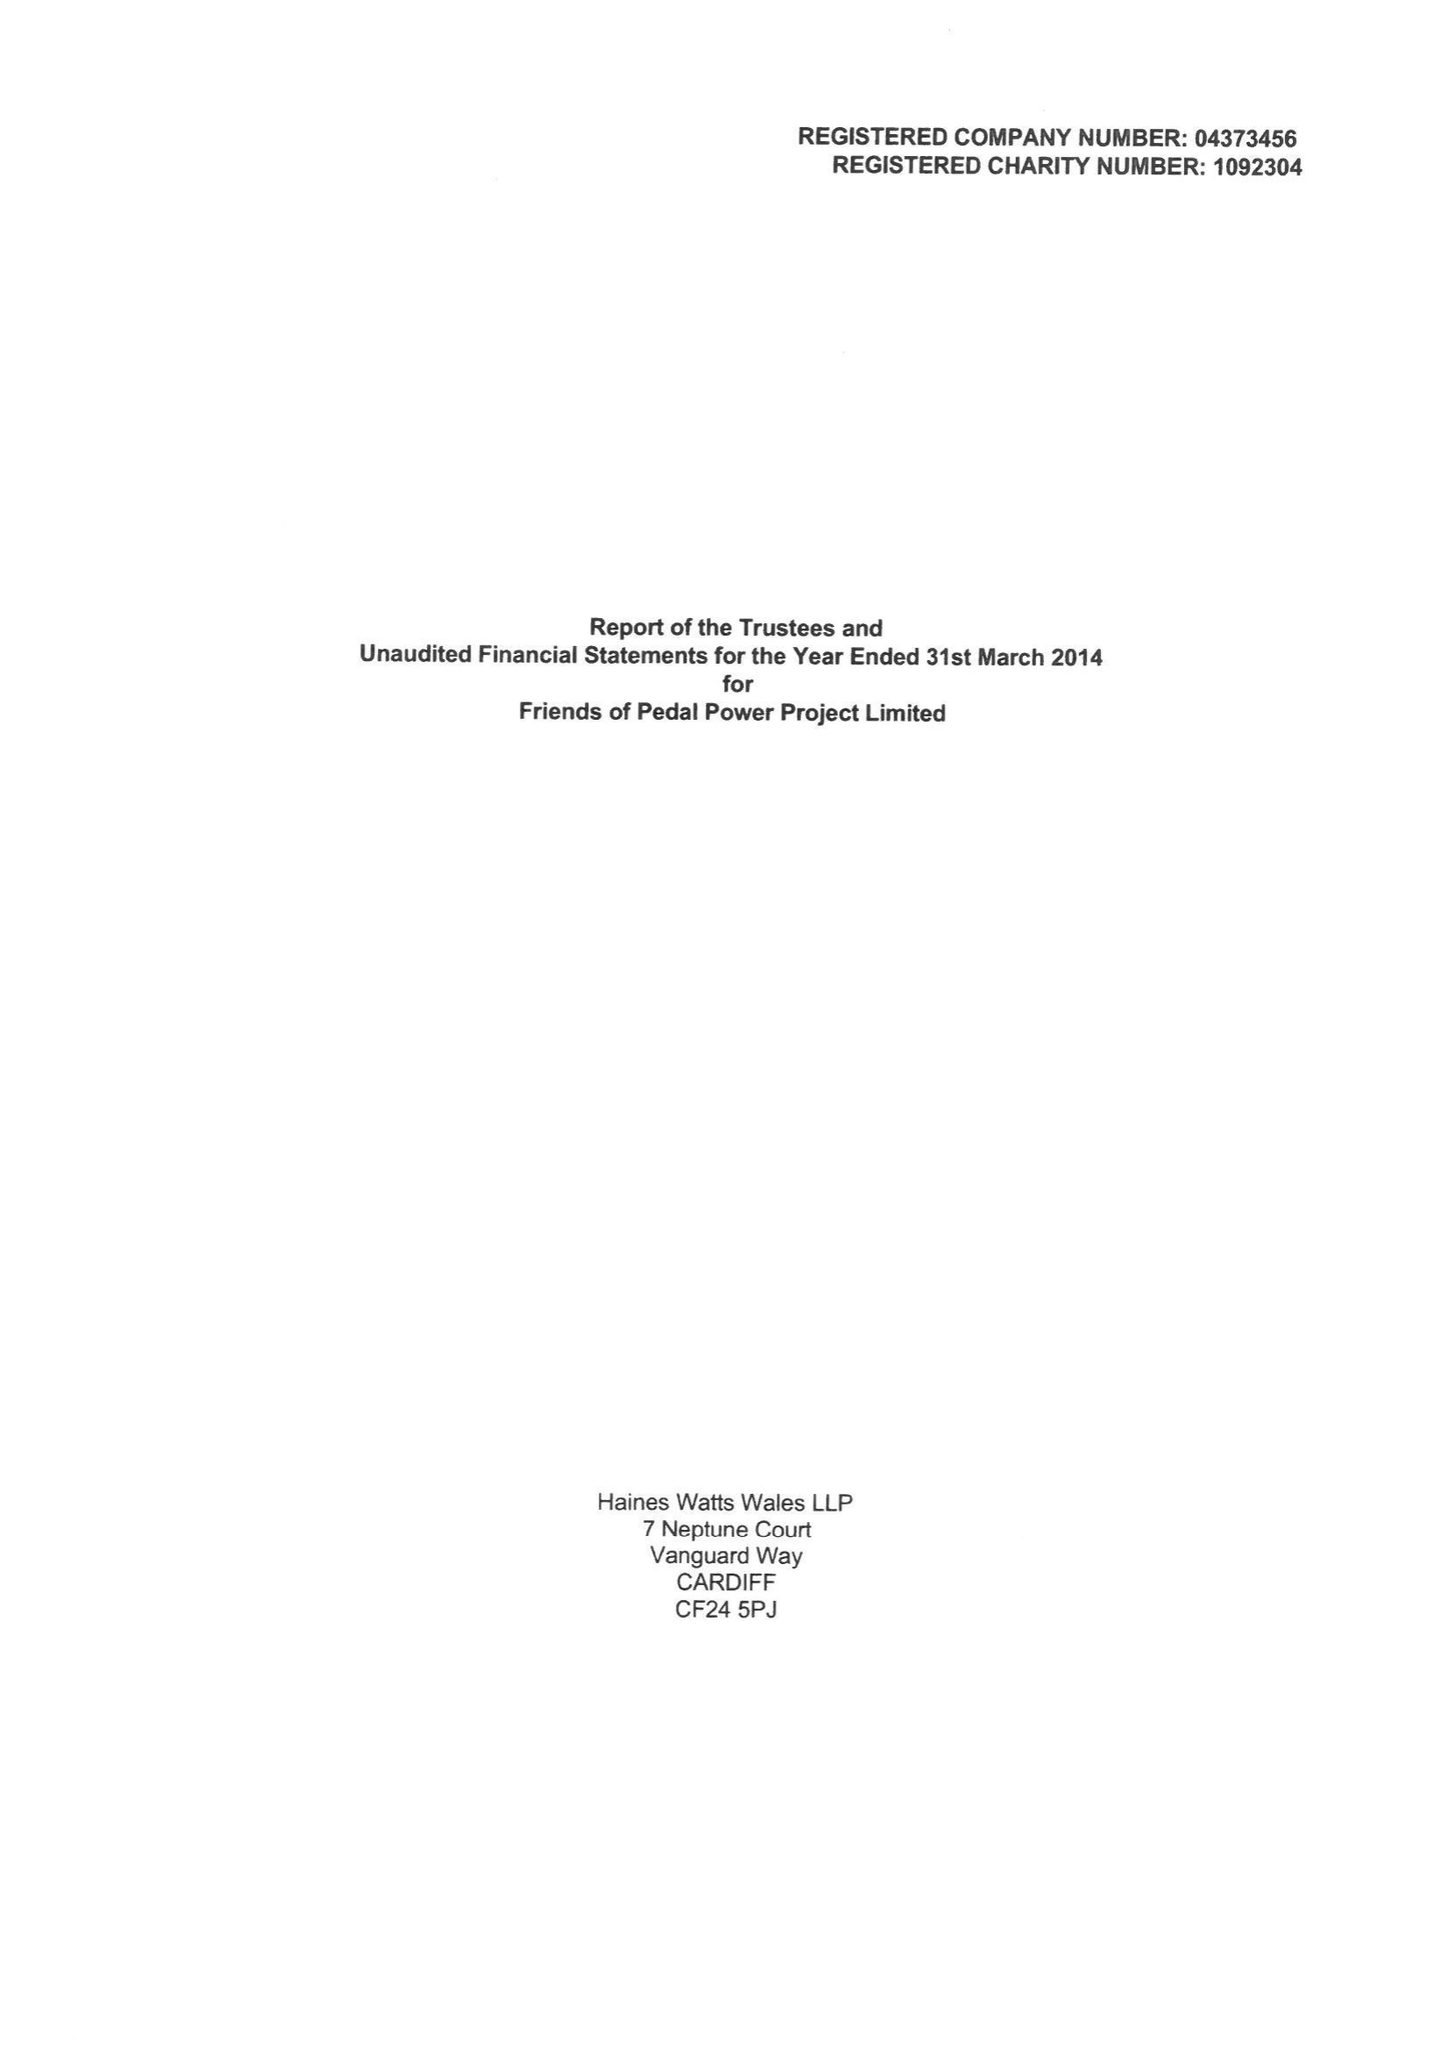What is the value for the income_annually_in_british_pounds?
Answer the question using a single word or phrase. 336237.00 